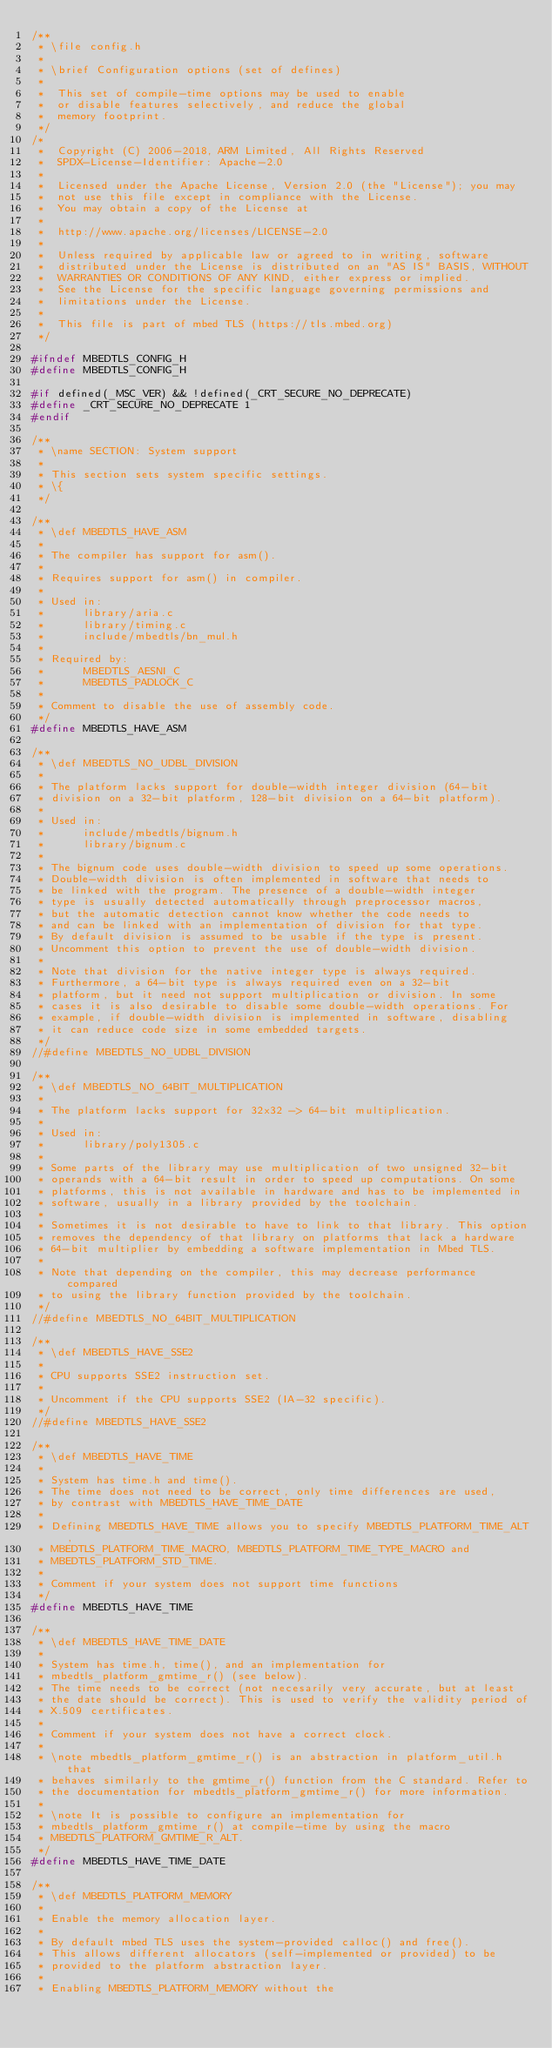<code> <loc_0><loc_0><loc_500><loc_500><_C_>/**
 * \file config.h
 *
 * \brief Configuration options (set of defines)
 *
 *  This set of compile-time options may be used to enable
 *  or disable features selectively, and reduce the global
 *  memory footprint.
 */
/*
 *  Copyright (C) 2006-2018, ARM Limited, All Rights Reserved
 *  SPDX-License-Identifier: Apache-2.0
 *
 *  Licensed under the Apache License, Version 2.0 (the "License"); you may
 *  not use this file except in compliance with the License.
 *  You may obtain a copy of the License at
 *
 *  http://www.apache.org/licenses/LICENSE-2.0
 *
 *  Unless required by applicable law or agreed to in writing, software
 *  distributed under the License is distributed on an "AS IS" BASIS, WITHOUT
 *  WARRANTIES OR CONDITIONS OF ANY KIND, either express or implied.
 *  See the License for the specific language governing permissions and
 *  limitations under the License.
 *
 *  This file is part of mbed TLS (https://tls.mbed.org)
 */

#ifndef MBEDTLS_CONFIG_H
#define MBEDTLS_CONFIG_H

#if defined(_MSC_VER) && !defined(_CRT_SECURE_NO_DEPRECATE)
#define _CRT_SECURE_NO_DEPRECATE 1
#endif

/**
 * \name SECTION: System support
 *
 * This section sets system specific settings.
 * \{
 */

/**
 * \def MBEDTLS_HAVE_ASM
 *
 * The compiler has support for asm().
 *
 * Requires support for asm() in compiler.
 *
 * Used in:
 *      library/aria.c
 *      library/timing.c
 *      include/mbedtls/bn_mul.h
 *
 * Required by:
 *      MBEDTLS_AESNI_C
 *      MBEDTLS_PADLOCK_C
 *
 * Comment to disable the use of assembly code.
 */
#define MBEDTLS_HAVE_ASM

/**
 * \def MBEDTLS_NO_UDBL_DIVISION
 *
 * The platform lacks support for double-width integer division (64-bit
 * division on a 32-bit platform, 128-bit division on a 64-bit platform).
 *
 * Used in:
 *      include/mbedtls/bignum.h
 *      library/bignum.c
 *
 * The bignum code uses double-width division to speed up some operations.
 * Double-width division is often implemented in software that needs to
 * be linked with the program. The presence of a double-width integer
 * type is usually detected automatically through preprocessor macros,
 * but the automatic detection cannot know whether the code needs to
 * and can be linked with an implementation of division for that type.
 * By default division is assumed to be usable if the type is present.
 * Uncomment this option to prevent the use of double-width division.
 *
 * Note that division for the native integer type is always required.
 * Furthermore, a 64-bit type is always required even on a 32-bit
 * platform, but it need not support multiplication or division. In some
 * cases it is also desirable to disable some double-width operations. For
 * example, if double-width division is implemented in software, disabling
 * it can reduce code size in some embedded targets.
 */
//#define MBEDTLS_NO_UDBL_DIVISION

/**
 * \def MBEDTLS_NO_64BIT_MULTIPLICATION
 *
 * The platform lacks support for 32x32 -> 64-bit multiplication.
 *
 * Used in:
 *      library/poly1305.c
 *
 * Some parts of the library may use multiplication of two unsigned 32-bit
 * operands with a 64-bit result in order to speed up computations. On some
 * platforms, this is not available in hardware and has to be implemented in
 * software, usually in a library provided by the toolchain.
 *
 * Sometimes it is not desirable to have to link to that library. This option
 * removes the dependency of that library on platforms that lack a hardware
 * 64-bit multiplier by embedding a software implementation in Mbed TLS.
 *
 * Note that depending on the compiler, this may decrease performance compared
 * to using the library function provided by the toolchain.
 */
//#define MBEDTLS_NO_64BIT_MULTIPLICATION

/**
 * \def MBEDTLS_HAVE_SSE2
 *
 * CPU supports SSE2 instruction set.
 *
 * Uncomment if the CPU supports SSE2 (IA-32 specific).
 */
//#define MBEDTLS_HAVE_SSE2

/**
 * \def MBEDTLS_HAVE_TIME
 *
 * System has time.h and time().
 * The time does not need to be correct, only time differences are used,
 * by contrast with MBEDTLS_HAVE_TIME_DATE
 *
 * Defining MBEDTLS_HAVE_TIME allows you to specify MBEDTLS_PLATFORM_TIME_ALT,
 * MBEDTLS_PLATFORM_TIME_MACRO, MBEDTLS_PLATFORM_TIME_TYPE_MACRO and
 * MBEDTLS_PLATFORM_STD_TIME.
 *
 * Comment if your system does not support time functions
 */
#define MBEDTLS_HAVE_TIME

/**
 * \def MBEDTLS_HAVE_TIME_DATE
 *
 * System has time.h, time(), and an implementation for
 * mbedtls_platform_gmtime_r() (see below).
 * The time needs to be correct (not necesarily very accurate, but at least
 * the date should be correct). This is used to verify the validity period of
 * X.509 certificates.
 *
 * Comment if your system does not have a correct clock.
 *
 * \note mbedtls_platform_gmtime_r() is an abstraction in platform_util.h that
 * behaves similarly to the gmtime_r() function from the C standard. Refer to
 * the documentation for mbedtls_platform_gmtime_r() for more information.
 *
 * \note It is possible to configure an implementation for
 * mbedtls_platform_gmtime_r() at compile-time by using the macro
 * MBEDTLS_PLATFORM_GMTIME_R_ALT.
 */
#define MBEDTLS_HAVE_TIME_DATE

/**
 * \def MBEDTLS_PLATFORM_MEMORY
 *
 * Enable the memory allocation layer.
 *
 * By default mbed TLS uses the system-provided calloc() and free().
 * This allows different allocators (self-implemented or provided) to be
 * provided to the platform abstraction layer.
 *
 * Enabling MBEDTLS_PLATFORM_MEMORY without the</code> 